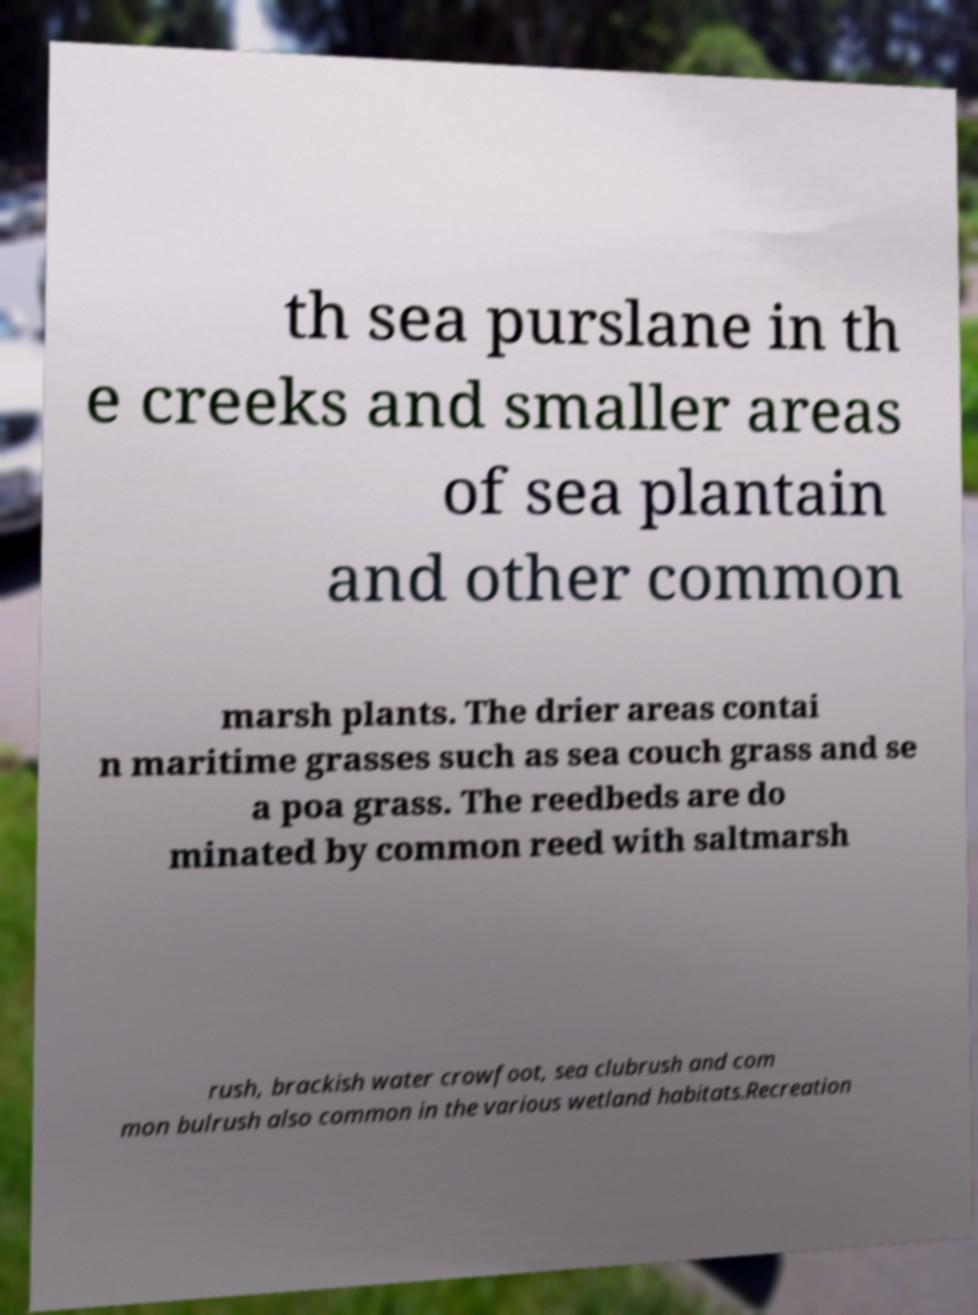Could you assist in decoding the text presented in this image and type it out clearly? th sea purslane in th e creeks and smaller areas of sea plantain and other common marsh plants. The drier areas contai n maritime grasses such as sea couch grass and se a poa grass. The reedbeds are do minated by common reed with saltmarsh rush, brackish water crowfoot, sea clubrush and com mon bulrush also common in the various wetland habitats.Recreation 